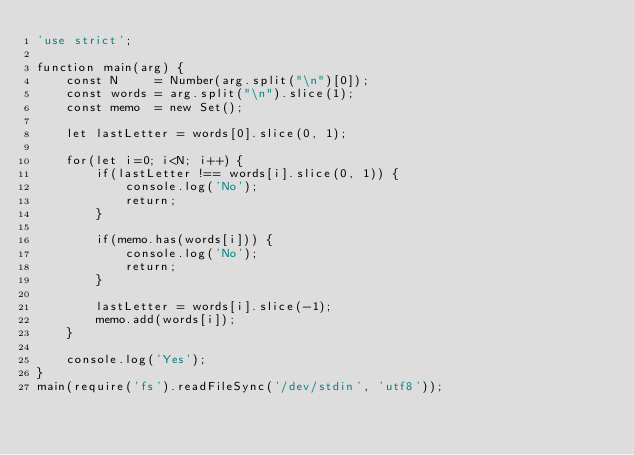<code> <loc_0><loc_0><loc_500><loc_500><_JavaScript_>'use strict';

function main(arg) {
    const N     = Number(arg.split("\n")[0]);
    const words = arg.split("\n").slice(1);
    const memo  = new Set();
    
    let lastLetter = words[0].slice(0, 1);

    for(let i=0; i<N; i++) {
        if(lastLetter !== words[i].slice(0, 1)) {
            console.log('No');
            return;
        }
        
        if(memo.has(words[i])) {
            console.log('No');
            return;
        }

        lastLetter = words[i].slice(-1);
        memo.add(words[i]);
    }
    
    console.log('Yes');
}
main(require('fs').readFileSync('/dev/stdin', 'utf8'));
</code> 